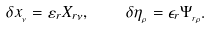<formula> <loc_0><loc_0><loc_500><loc_500>\delta x _ { _ { \nu } } = \varepsilon _ { r } X _ { r \nu } , \quad \delta \eta _ { _ { \rho } } = \epsilon _ { r } \Psi _ { _ { r \rho } } .</formula> 